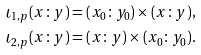Convert formula to latex. <formula><loc_0><loc_0><loc_500><loc_500>\iota _ { 1 , p } ( x \colon y ) & = ( x _ { 0 } \colon y _ { 0 } ) \times ( x \colon y ) , \\ \iota _ { 2 , p } ( x \colon y ) & = ( x \colon y ) \times ( x _ { 0 } \colon y _ { 0 } ) .</formula> 